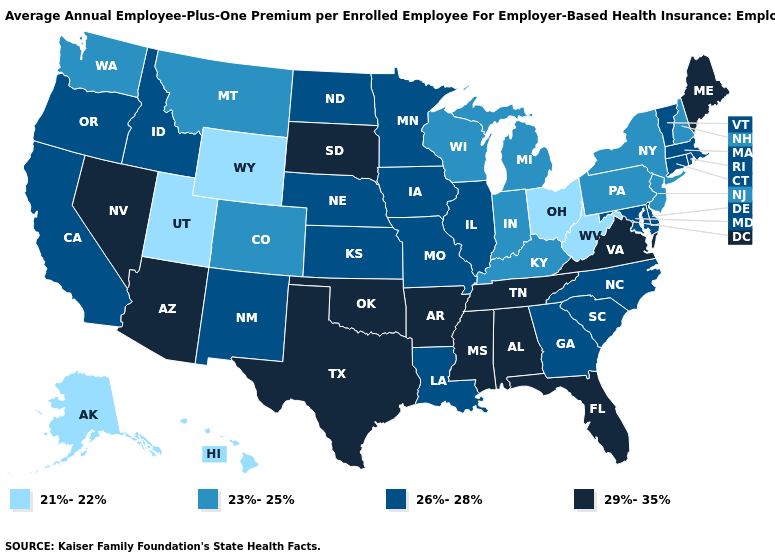Name the states that have a value in the range 21%-22%?
Answer briefly. Alaska, Hawaii, Ohio, Utah, West Virginia, Wyoming. Which states hav the highest value in the MidWest?
Concise answer only. South Dakota. What is the lowest value in the USA?
Keep it brief. 21%-22%. Does New Jersey have the same value as Georgia?
Keep it brief. No. Name the states that have a value in the range 26%-28%?
Concise answer only. California, Connecticut, Delaware, Georgia, Idaho, Illinois, Iowa, Kansas, Louisiana, Maryland, Massachusetts, Minnesota, Missouri, Nebraska, New Mexico, North Carolina, North Dakota, Oregon, Rhode Island, South Carolina, Vermont. Does the first symbol in the legend represent the smallest category?
Give a very brief answer. Yes. Name the states that have a value in the range 23%-25%?
Quick response, please. Colorado, Indiana, Kentucky, Michigan, Montana, New Hampshire, New Jersey, New York, Pennsylvania, Washington, Wisconsin. What is the highest value in states that border West Virginia?
Be succinct. 29%-35%. Name the states that have a value in the range 21%-22%?
Keep it brief. Alaska, Hawaii, Ohio, Utah, West Virginia, Wyoming. Name the states that have a value in the range 29%-35%?
Be succinct. Alabama, Arizona, Arkansas, Florida, Maine, Mississippi, Nevada, Oklahoma, South Dakota, Tennessee, Texas, Virginia. Is the legend a continuous bar?
Answer briefly. No. Is the legend a continuous bar?
Answer briefly. No. What is the value of Illinois?
Keep it brief. 26%-28%. Among the states that border Nevada , which have the highest value?
Answer briefly. Arizona. What is the value of Vermont?
Answer briefly. 26%-28%. 